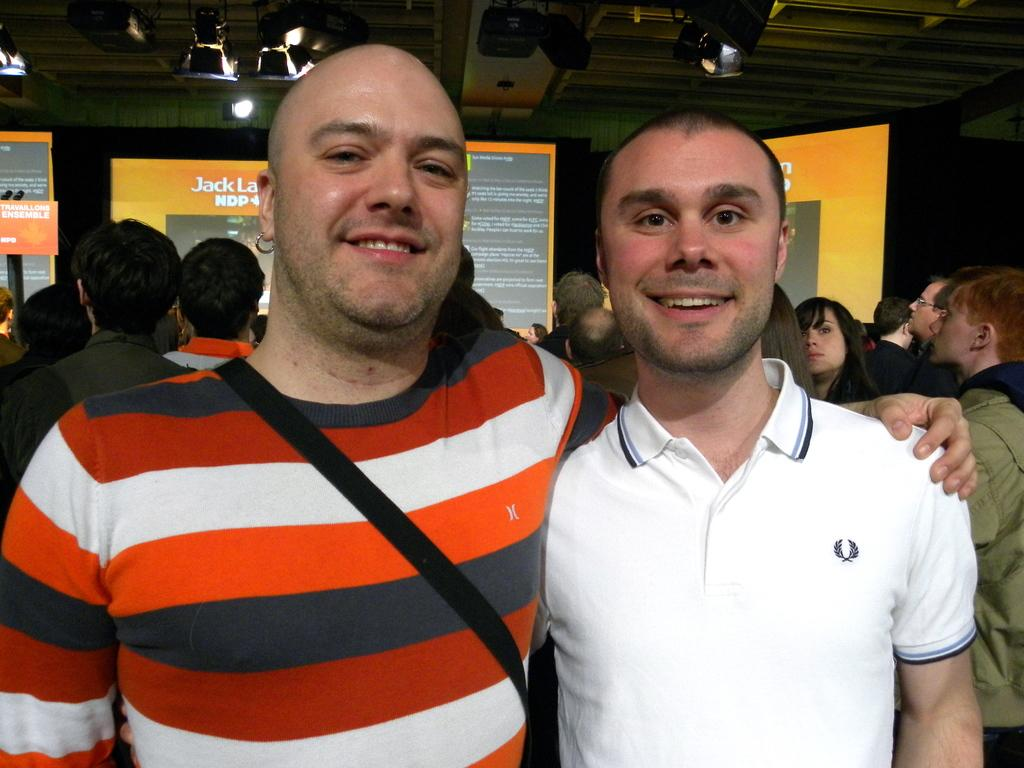<image>
Summarize the visual content of the image. Two men smiling with presentation behind them with the word Jack displayed. 